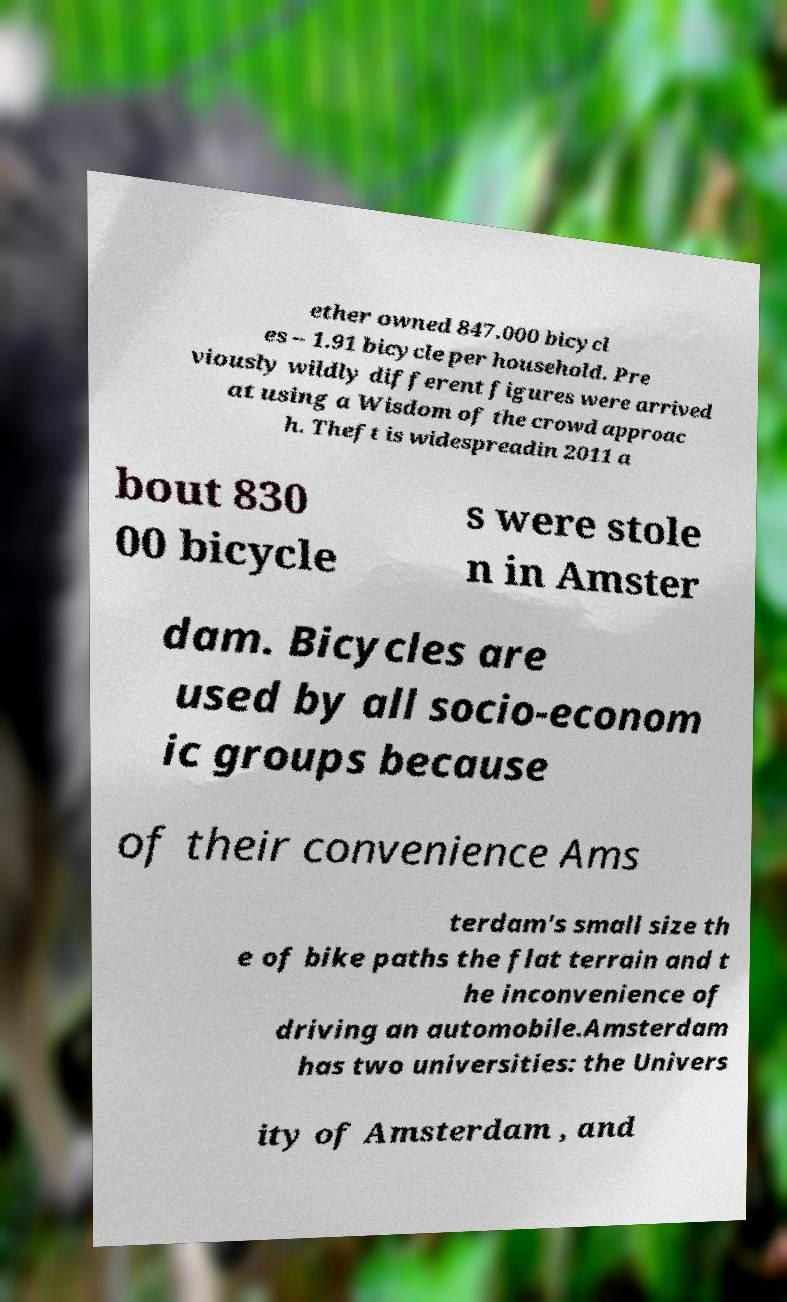There's text embedded in this image that I need extracted. Can you transcribe it verbatim? ether owned 847.000 bicycl es – 1.91 bicycle per household. Pre viously wildly different figures were arrived at using a Wisdom of the crowd approac h. Theft is widespreadin 2011 a bout 830 00 bicycle s were stole n in Amster dam. Bicycles are used by all socio-econom ic groups because of their convenience Ams terdam's small size th e of bike paths the flat terrain and t he inconvenience of driving an automobile.Amsterdam has two universities: the Univers ity of Amsterdam , and 